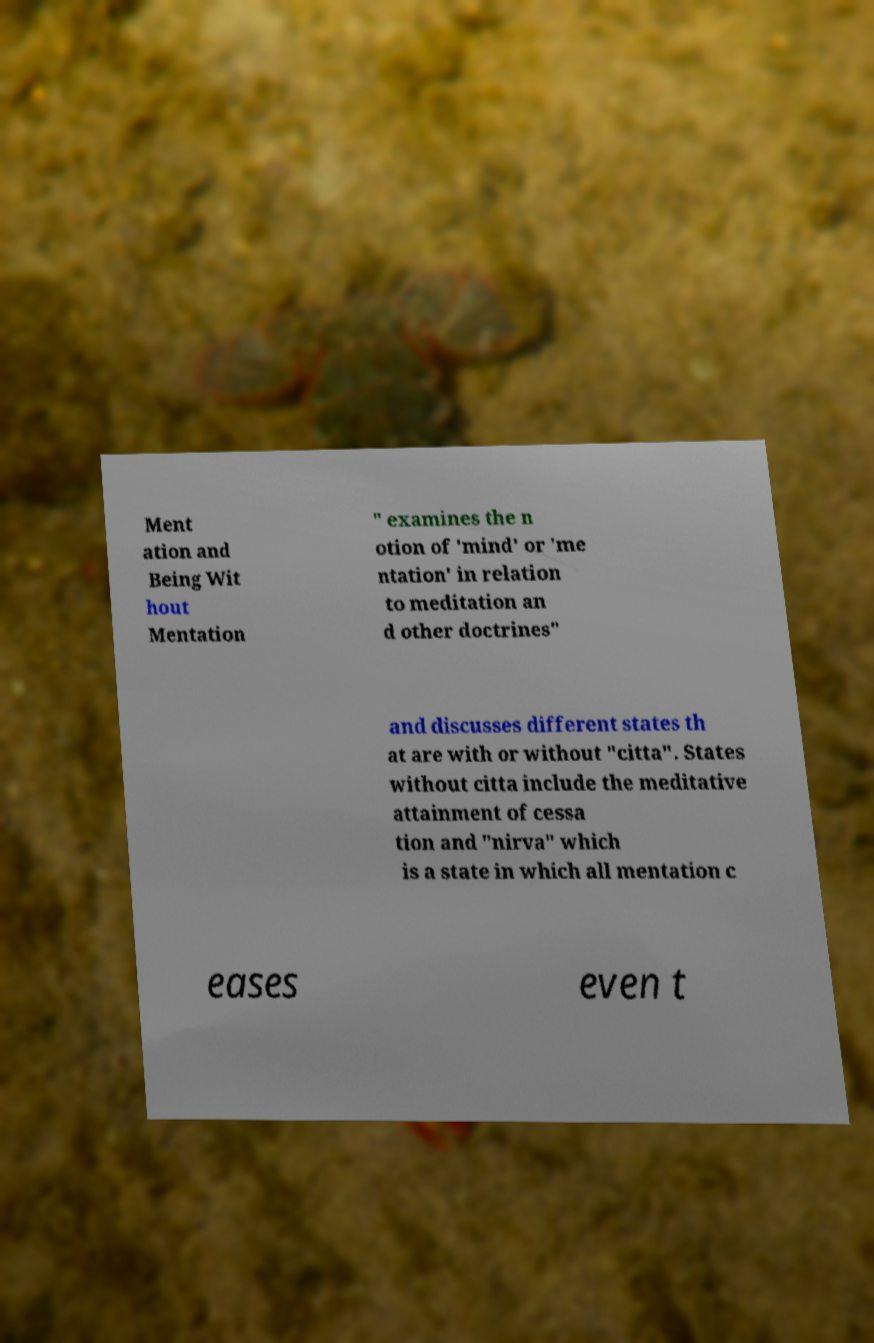I need the written content from this picture converted into text. Can you do that? Ment ation and Being Wit hout Mentation " examines the n otion of 'mind' or 'me ntation' in relation to meditation an d other doctrines" and discusses different states th at are with or without "citta". States without citta include the meditative attainment of cessa tion and "nirva" which is a state in which all mentation c eases even t 